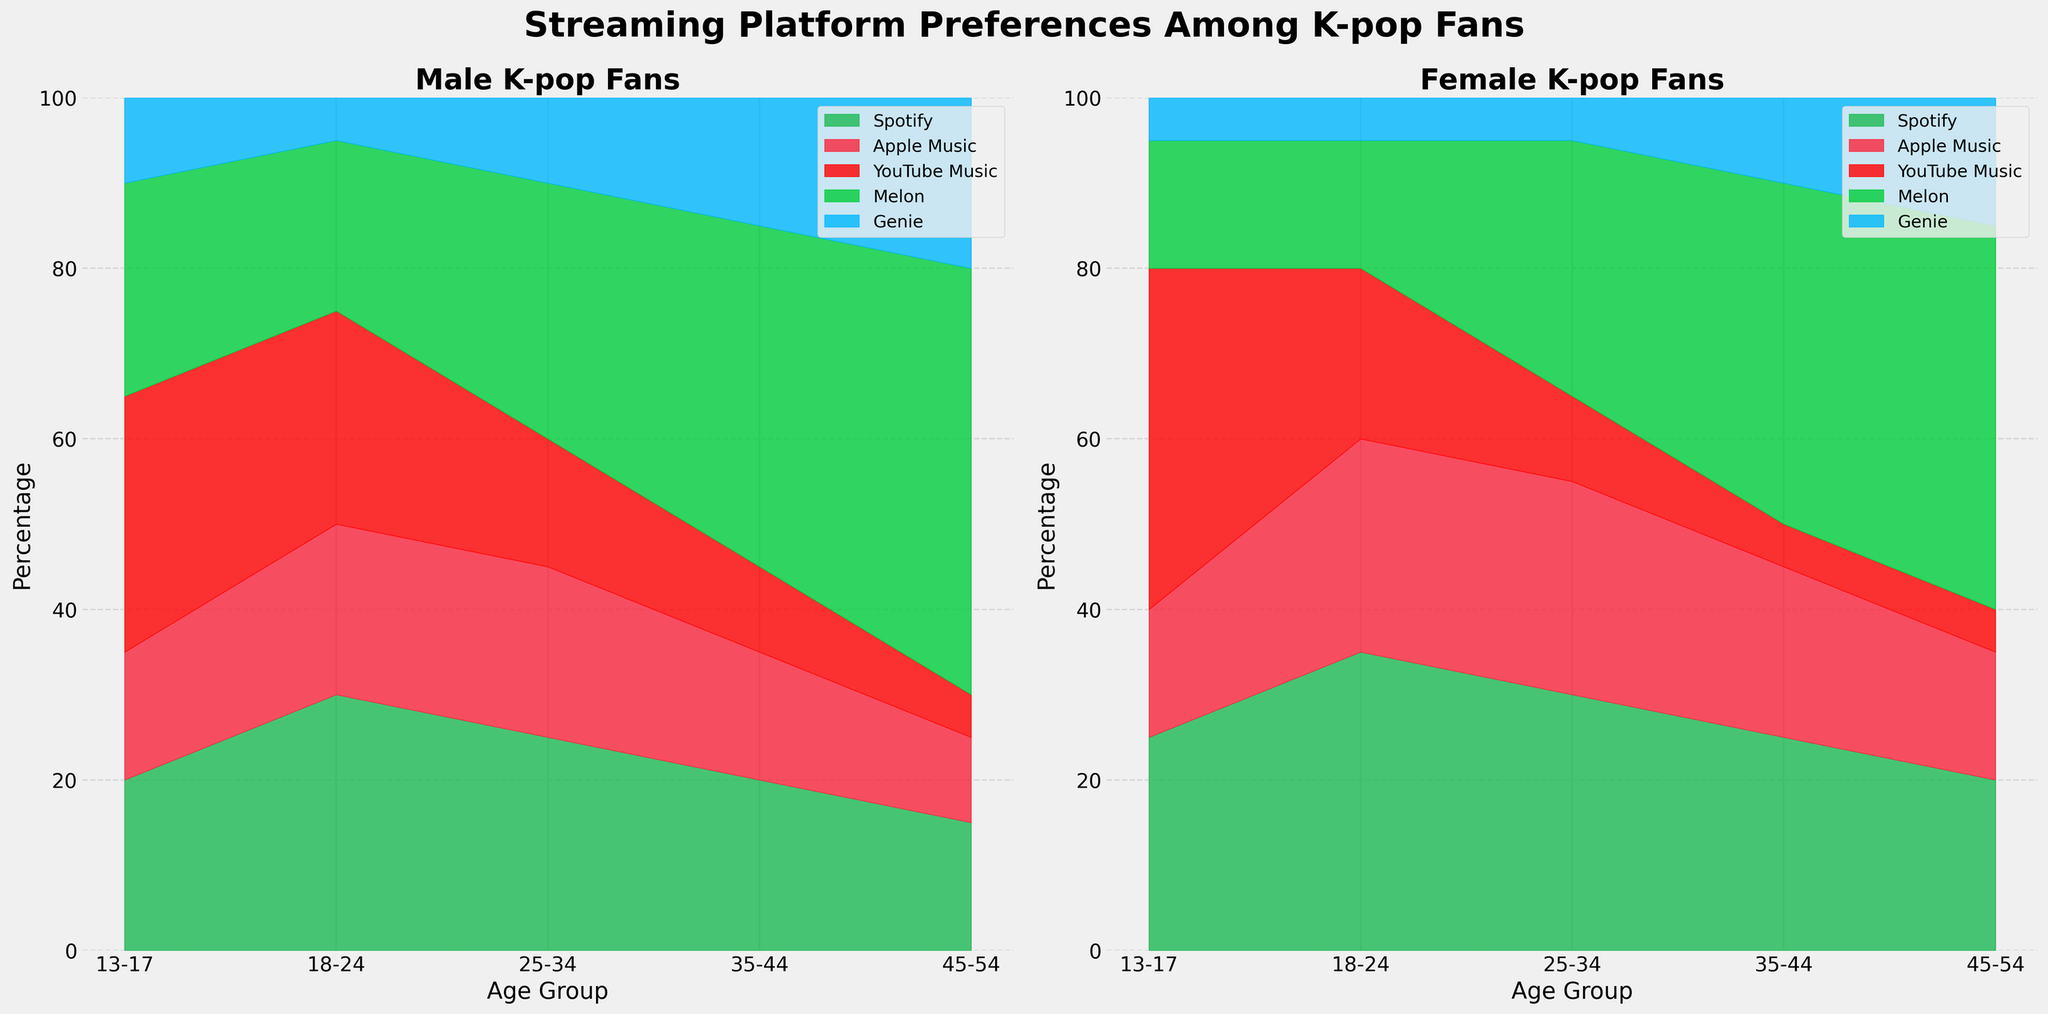What is the title of the figure? The title of the figure is located at the top of the figure. Reading from the figure, the title is "Streaming Platform Preferences Among K-pop Fans".
Answer: Streaming Platform Preferences Among K-pop Fans Which gender has a subplot on the left side? The gender subplot on the left side can be identified by looking at the individual titles of the subplots. The title for the left subplot is "Male K-pop Fans".
Answer: Male What streaming platform has the highest preference among 13-17-year-old female K-pop fans? For 13-17-year-old female K-pop fans, the heights of the segments representing different platforms above the age group “13-17” need to be compared. The tallest segment belongs to YouTube Music.
Answer: YouTube Music Compare the preference for Spotify between 18-24-year-old male and female K-pop fans. Which gender prefers it more? By comparing the heights of the segments representing Spotify for age group 18-24 between male and female subplots, the female group shows a taller segment. This indicates a higher preference among females.
Answer: Female In the 25-34 age group, which streaming platform shows the largest difference in preference between males and females? To find the platform with the largest difference, we compare the segments representing each platform between the male and female subplots for the age group 25-34. Melon shows the largest difference with males at 30 and females at 10, a difference of 20.
Answer: Melon What is the combined preference for Melon and Genie among 35-44-year-old male K-pop fans? To find the combined preference, add the segments representing Melon and Genie above the age group 35-44 in the male subplot. The segments are 40 for Melon and 15 for Genie, so the total is 40 + 15 = 55.
Answer: 55 How does the preference for Apple Music change across different age groups for female K-pop fans? By observing the heights of the segments representing Apple Music in the female subplot across different age groups (13-17, 18-24, 25-34, 35-44, 45-54), it starts at 15, increases to 25, remains at 25, and then slightly decreases to 20 and 15 respectively.
Answer: Increases, then slightly decreases For the age group 45-54, which gender has a higher combined preference for all streaming platforms? By summing up the segments representing all platforms in the 45-54 age group for both male and female subplots and then comparing them, males have a higher combined preference (15 + 10 + 5 + 50 + 20 = 100) compared to females (20 + 15 + 5 + 45 + 15 = 100).
Answer: Equal Which platform has the least preference among 18-24-year-old male K-pop fans? By comparing the heights of the segments representing different platforms for the age group 18-24 in the male subplot, the shortest segment belongs to Genie, indicating the least preference.
Answer: Genie 